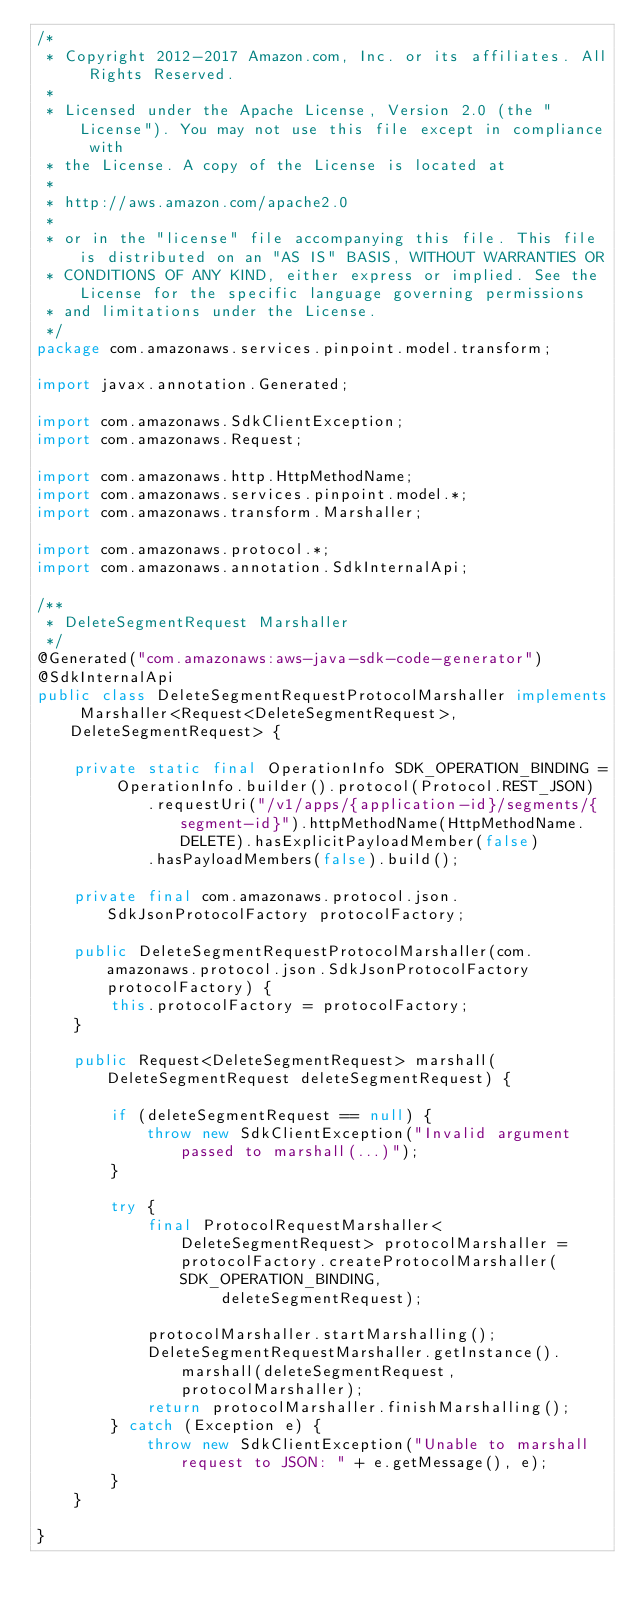Convert code to text. <code><loc_0><loc_0><loc_500><loc_500><_Java_>/*
 * Copyright 2012-2017 Amazon.com, Inc. or its affiliates. All Rights Reserved.
 * 
 * Licensed under the Apache License, Version 2.0 (the "License"). You may not use this file except in compliance with
 * the License. A copy of the License is located at
 * 
 * http://aws.amazon.com/apache2.0
 * 
 * or in the "license" file accompanying this file. This file is distributed on an "AS IS" BASIS, WITHOUT WARRANTIES OR
 * CONDITIONS OF ANY KIND, either express or implied. See the License for the specific language governing permissions
 * and limitations under the License.
 */
package com.amazonaws.services.pinpoint.model.transform;

import javax.annotation.Generated;

import com.amazonaws.SdkClientException;
import com.amazonaws.Request;

import com.amazonaws.http.HttpMethodName;
import com.amazonaws.services.pinpoint.model.*;
import com.amazonaws.transform.Marshaller;

import com.amazonaws.protocol.*;
import com.amazonaws.annotation.SdkInternalApi;

/**
 * DeleteSegmentRequest Marshaller
 */
@Generated("com.amazonaws:aws-java-sdk-code-generator")
@SdkInternalApi
public class DeleteSegmentRequestProtocolMarshaller implements Marshaller<Request<DeleteSegmentRequest>, DeleteSegmentRequest> {

    private static final OperationInfo SDK_OPERATION_BINDING = OperationInfo.builder().protocol(Protocol.REST_JSON)
            .requestUri("/v1/apps/{application-id}/segments/{segment-id}").httpMethodName(HttpMethodName.DELETE).hasExplicitPayloadMember(false)
            .hasPayloadMembers(false).build();

    private final com.amazonaws.protocol.json.SdkJsonProtocolFactory protocolFactory;

    public DeleteSegmentRequestProtocolMarshaller(com.amazonaws.protocol.json.SdkJsonProtocolFactory protocolFactory) {
        this.protocolFactory = protocolFactory;
    }

    public Request<DeleteSegmentRequest> marshall(DeleteSegmentRequest deleteSegmentRequest) {

        if (deleteSegmentRequest == null) {
            throw new SdkClientException("Invalid argument passed to marshall(...)");
        }

        try {
            final ProtocolRequestMarshaller<DeleteSegmentRequest> protocolMarshaller = protocolFactory.createProtocolMarshaller(SDK_OPERATION_BINDING,
                    deleteSegmentRequest);

            protocolMarshaller.startMarshalling();
            DeleteSegmentRequestMarshaller.getInstance().marshall(deleteSegmentRequest, protocolMarshaller);
            return protocolMarshaller.finishMarshalling();
        } catch (Exception e) {
            throw new SdkClientException("Unable to marshall request to JSON: " + e.getMessage(), e);
        }
    }

}
</code> 